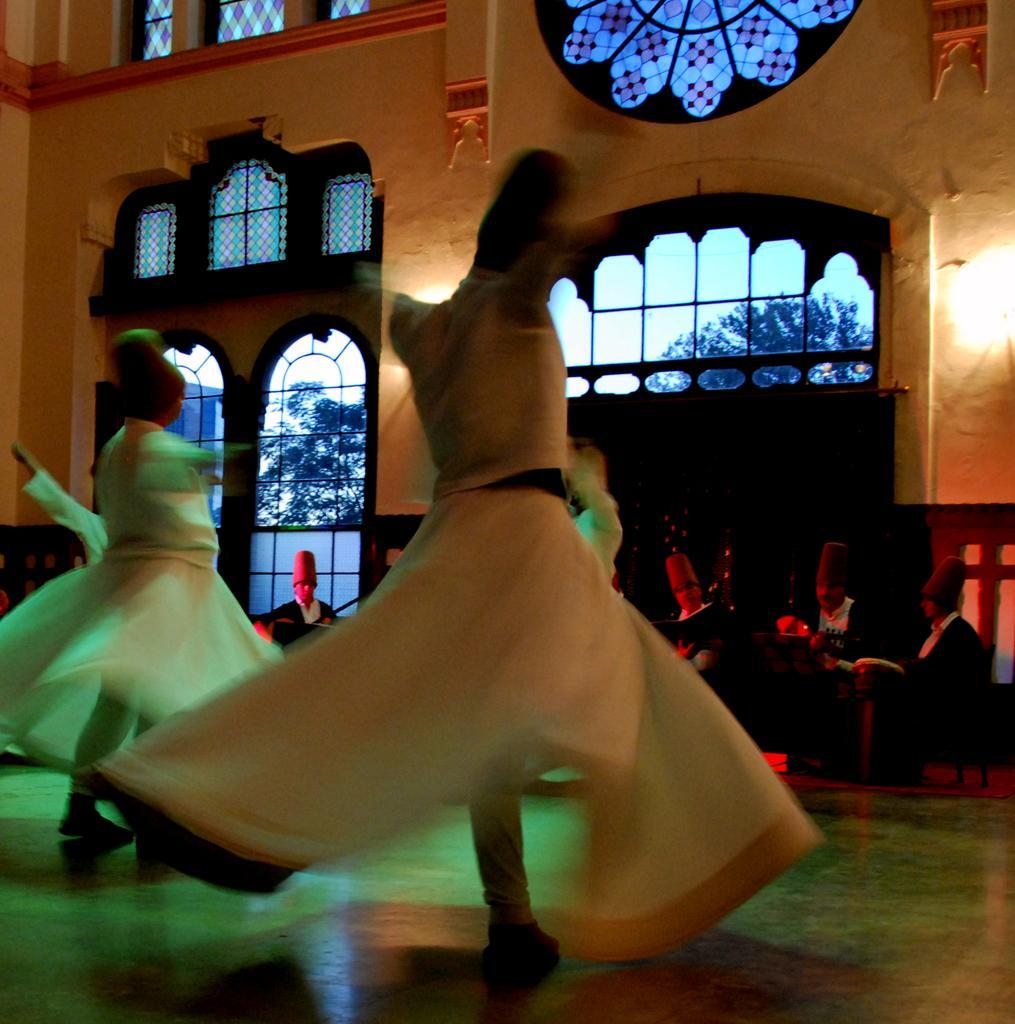Please provide a concise description of this image. In this image, we can see a few people. Among them, some people are sitting and some people are standing. We can also see the ground. There are some glass doors and glass windows. We can see the wall and some lights. 